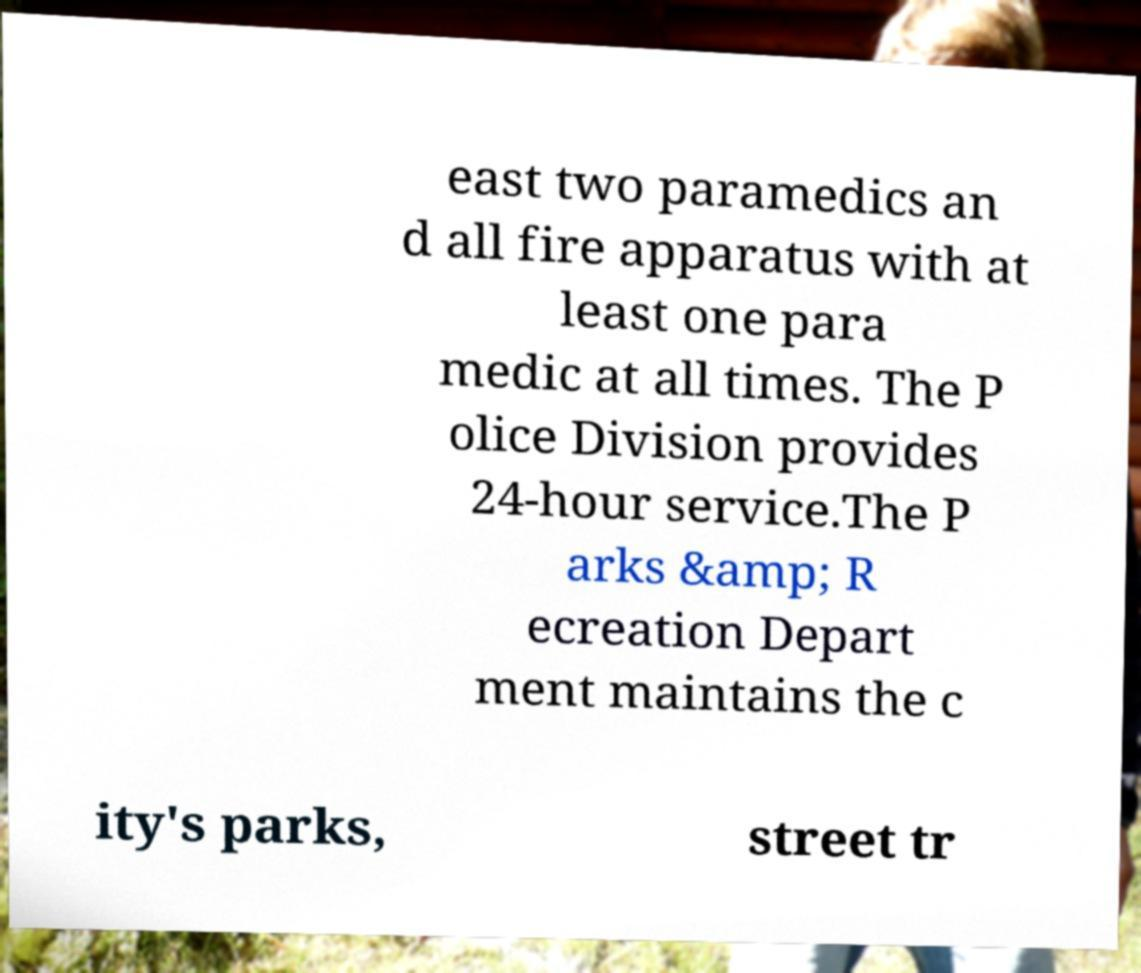For documentation purposes, I need the text within this image transcribed. Could you provide that? east two paramedics an d all fire apparatus with at least one para medic at all times. The P olice Division provides 24-hour service.The P arks &amp; R ecreation Depart ment maintains the c ity's parks, street tr 